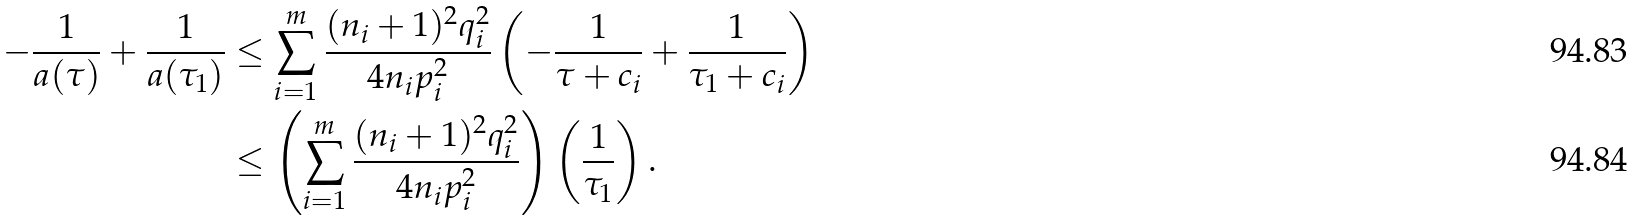<formula> <loc_0><loc_0><loc_500><loc_500>- \frac { 1 } { a ( \tau ) } + \frac { 1 } { a ( \tau _ { 1 } ) } & \leq \sum _ { i = 1 } ^ { m } \frac { ( n _ { i } + 1 ) ^ { 2 } q _ { i } ^ { 2 } } { 4 n _ { i } p _ { i } ^ { 2 } } \left ( - \frac { 1 } { \tau + c _ { i } } + \frac { 1 } { \tau _ { 1 } + c _ { i } } \right ) \\ & \leq \left ( \sum _ { i = 1 } ^ { m } \frac { ( n _ { i } + 1 ) ^ { 2 } q _ { i } ^ { 2 } } { 4 n _ { i } p _ { i } ^ { 2 } } \right ) \left ( \frac { 1 } { \tau _ { 1 } } \right ) .</formula> 